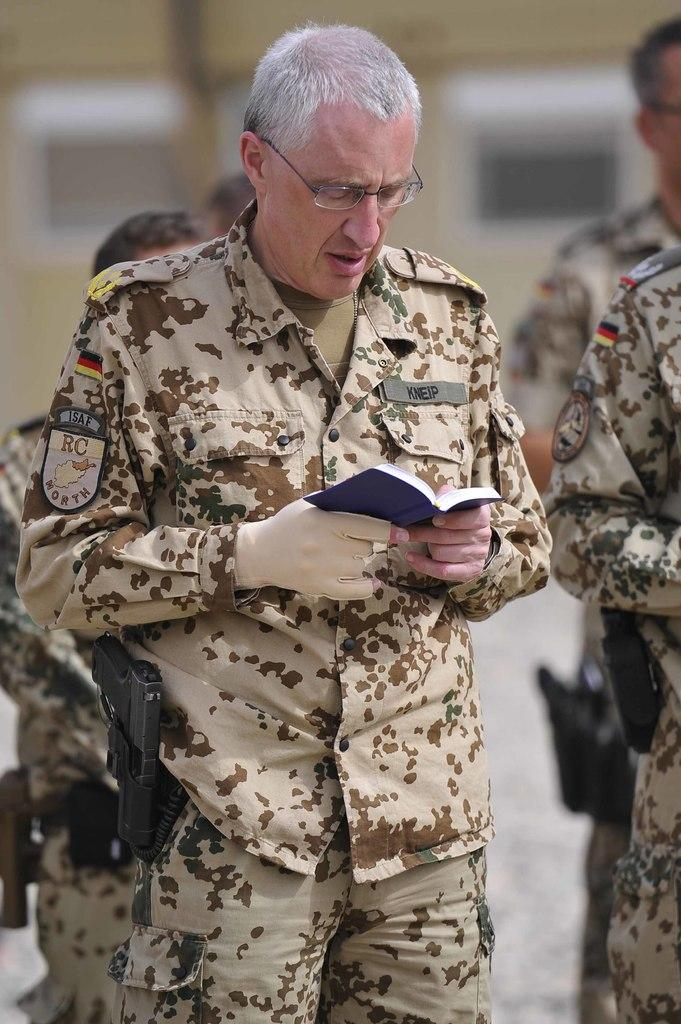How many people are in the image? There is a group of people in the image. What is one person doing in the image? One person is holding a book. Can you describe the background of the image? The background of the image is blurry. What theory is the kettle discussing with the group of people in the image? There is no kettle present in the image, and therefore no discussion involving a kettle can be observed. 